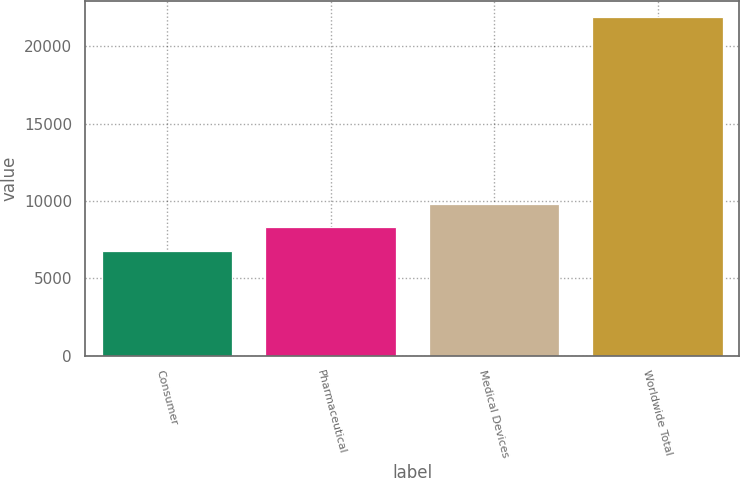<chart> <loc_0><loc_0><loc_500><loc_500><bar_chart><fcel>Consumer<fcel>Pharmaceutical<fcel>Medical Devices<fcel>Worldwide Total<nl><fcel>6787<fcel>8295.6<fcel>9804.2<fcel>21873<nl></chart> 